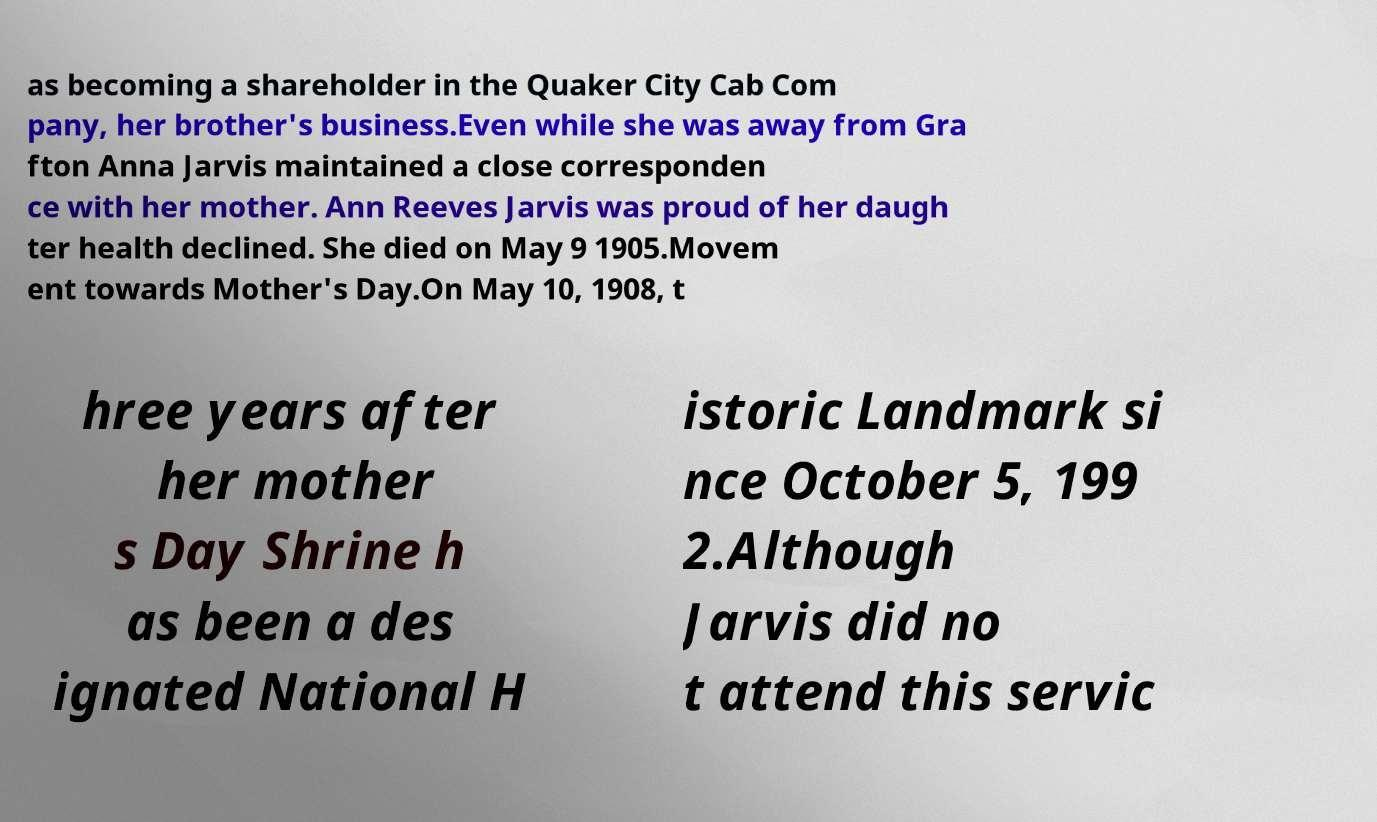Could you assist in decoding the text presented in this image and type it out clearly? as becoming a shareholder in the Quaker City Cab Com pany, her brother's business.Even while she was away from Gra fton Anna Jarvis maintained a close corresponden ce with her mother. Ann Reeves Jarvis was proud of her daugh ter health declined. She died on May 9 1905.Movem ent towards Mother's Day.On May 10, 1908, t hree years after her mother s Day Shrine h as been a des ignated National H istoric Landmark si nce October 5, 199 2.Although Jarvis did no t attend this servic 